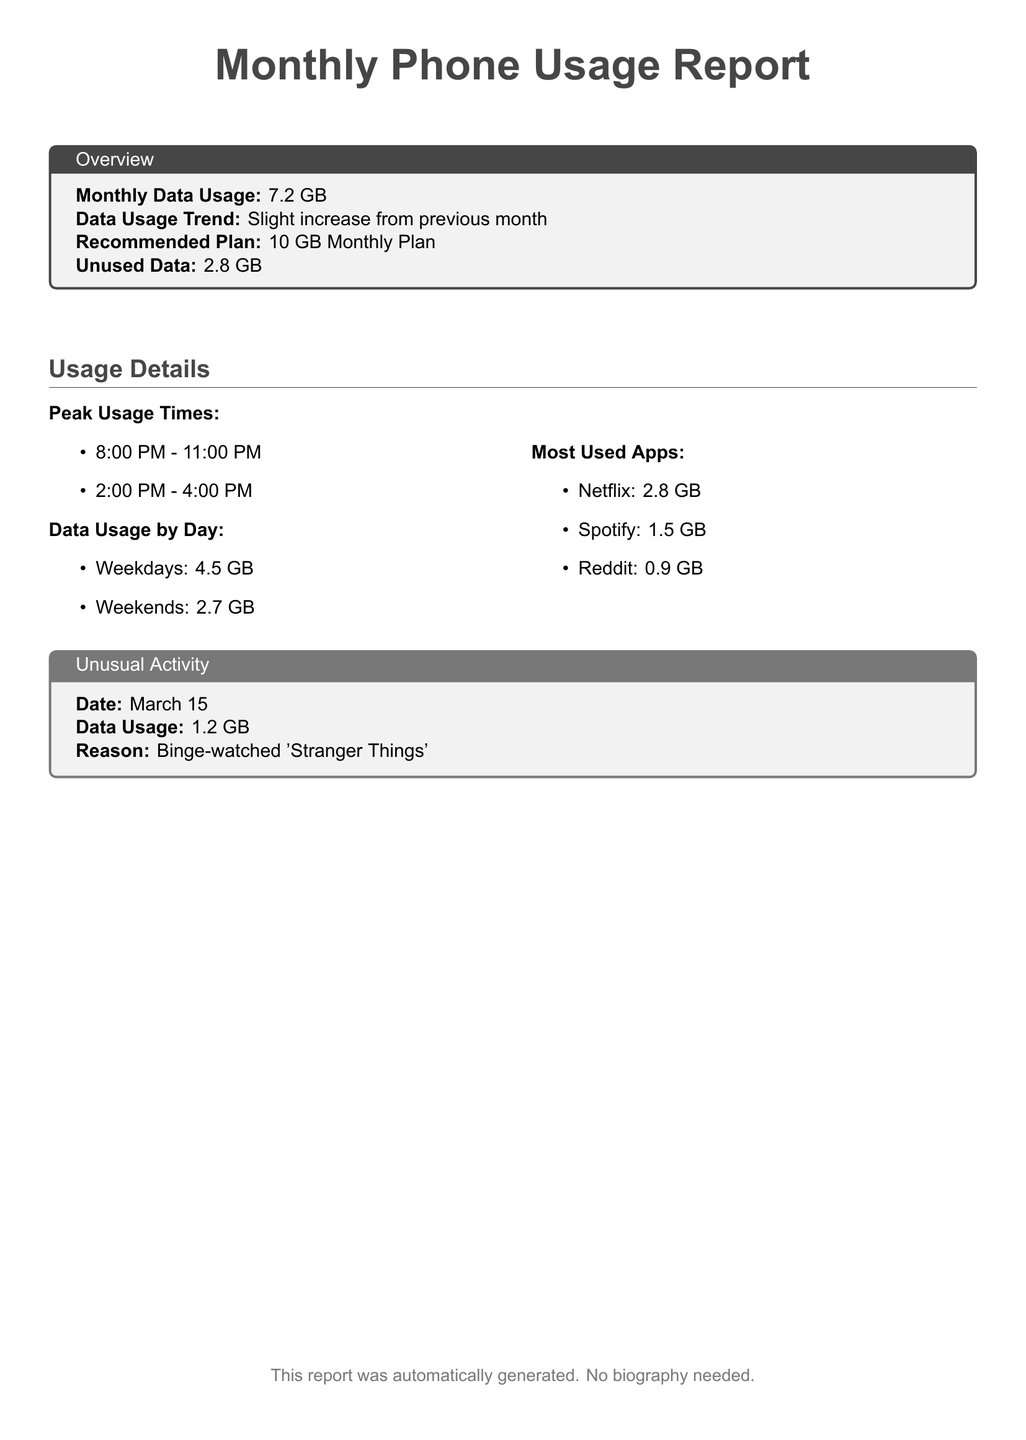what is the total monthly data usage? The total monthly data usage is stated clearly in the overview section of the report, which is 7.2 GB.
Answer: 7.2 GB what is the recommended data plan? The recommended plan is indicated in the overview section, suggesting a suitable option based on usage, which is a 10 GB Monthly Plan.
Answer: 10 GB Monthly Plan what are the peak usage times? The peak usage times are listed under "Peak Usage Times" and include two time ranges.
Answer: 8:00 PM - 11:00 PM, 2:00 PM - 4:00 PM how much data was used on weekdays? The report specifies data usage by day and indicates that weekdays used 4.5 GB.
Answer: 4.5 GB which app consumed the most data? The most used apps section indicates that the app consuming the most data is Netflix with 2.8 GB usage.
Answer: Netflix what was the data usage on March 15? The unusual activity section records the specific date and its data usage, which is 1.2 GB on that date.
Answer: 1.2 GB what is the data usage trend compared to the previous month? The overview mentions the data usage trend, which is described as a slight increase from the previous month.
Answer: Slight increase how much unused data is there? The overview specifies the amount of unused data remaining at the end of the month, which is 2.8 GB.
Answer: 2.8 GB which app is used the least? The most used apps section lists usage amounts for each app, indicating that Reddit is used the least at 0.9 GB.
Answer: Reddit 